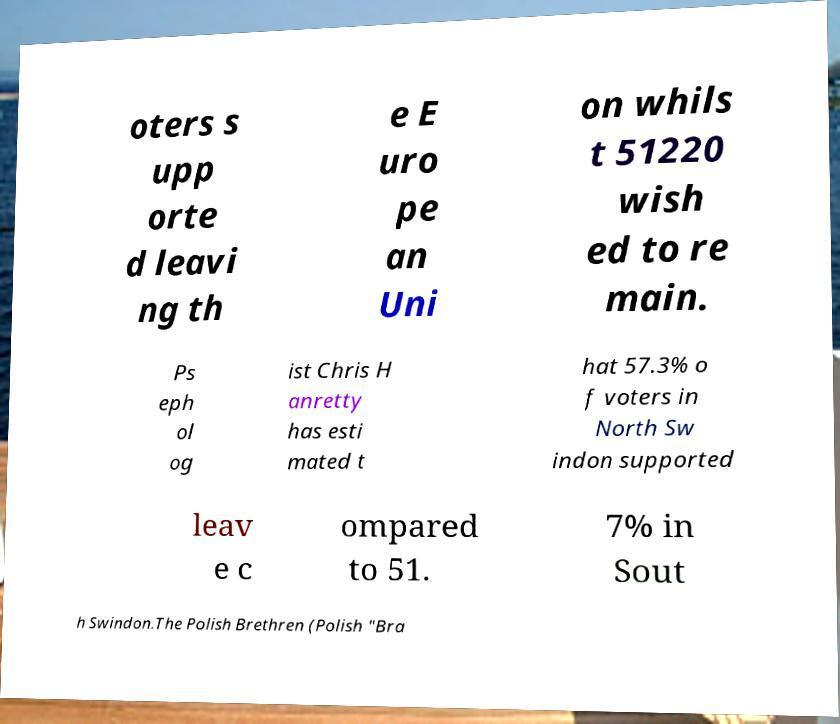For documentation purposes, I need the text within this image transcribed. Could you provide that? oters s upp orte d leavi ng th e E uro pe an Uni on whils t 51220 wish ed to re main. Ps eph ol og ist Chris H anretty has esti mated t hat 57.3% o f voters in North Sw indon supported leav e c ompared to 51. 7% in Sout h Swindon.The Polish Brethren (Polish "Bra 